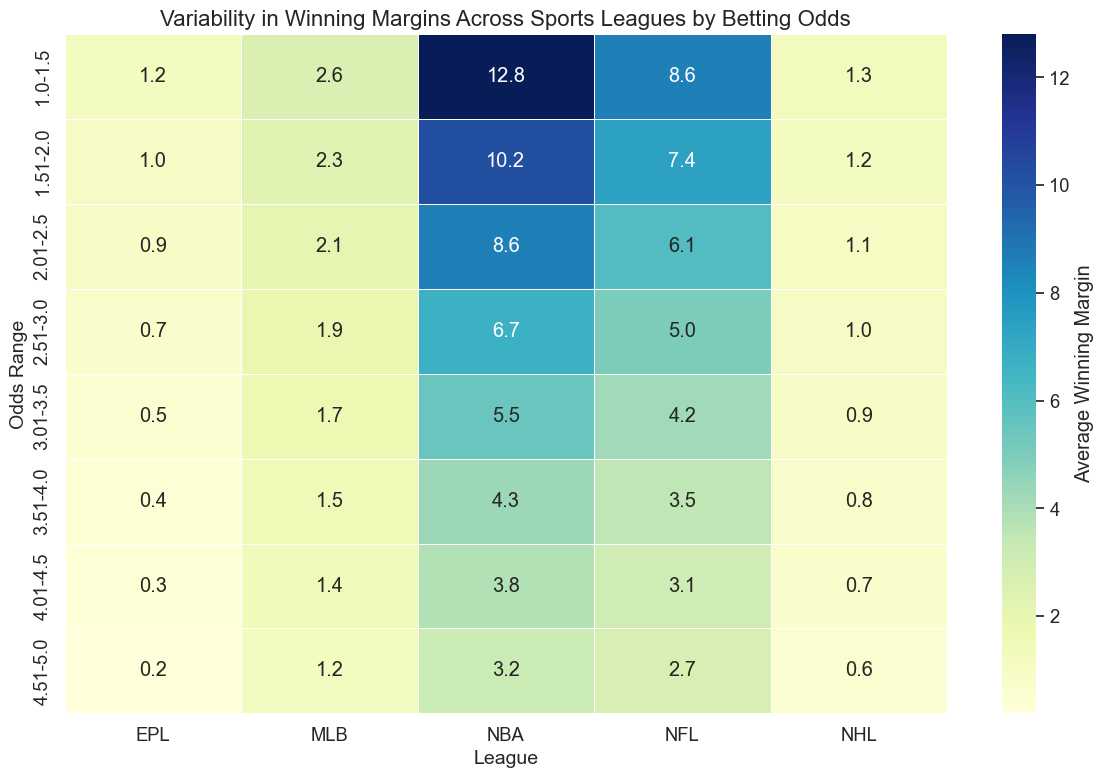Which league has the highest average winning margin in the 1.0-1.5 odds range? First, find the 1.0-1.5 odds range row in the heatmap. Then, look across the leagues to identify the largest value within that row. The NBA has an average winning margin of 12.8, which is the highest.
Answer: NBA How does the average winning margin for the NFL compare to the EPL at odds range 2.51-3.0? In the heatmap, locate the 2.51-3.0 odds range row. Then compare the values for the NFL and the EPL in this row. The NFL has an average margin of 5.0, while the EPL has 0.7. The NFL's margin is larger.
Answer: NFL's is larger Which odds range shows the highest variability (standard deviation) in winning margin for the NBA? Generally, variability isn't directly shown in the heatmap. Based on the given data, the highest standard deviation for NBA is in the 4.51-5.0 odds range, which is 10.0.
Answer: 4.51-5.0 In which league and odds range do we see the smallest average winning margin? Search for the smallest value in the entire heatmap. This is for the EPL league and the 4.51-5.0 odds range with an average margin of 0.2.
Answer: EPL, 4.51-5.0 Which league shows consistently decreasing average winning margins as the odds increase from 1.0-1.5 to 4.51-5.0? To verify this, we need to inspect each league column to ensure that the values strictly decrease as we go from the top to the bottom row. The average margins decrease in the NBA league consistently.
Answer: NBA What is the difference in average winning margin between the NBA and MLB at odds range 2.01-2.5? Locate the 2.01-2.5 odds range row, then identify the values for NBA and MLB in this row. Subtract the MLB value (2.1) from the NBA value (8.6). 8.6 - 2.1 = 6.5.
Answer: 6.5 Which league has the least variability in winning margins regardless of the odds range? The EPL has the smallest standard deviations at each odds range according to the data, indicating the least variability.
Answer: EPL What is the combined average winning margin for the NFL and NHL at odds range 3.0-3.5? Locate the 3.0-3.5 odds range row, then find the values for NFL (4.2) and NHL (0.9). Add these values together to get the total average margin. 4.2 + 0.9 = 5.1.
Answer: 5.1 